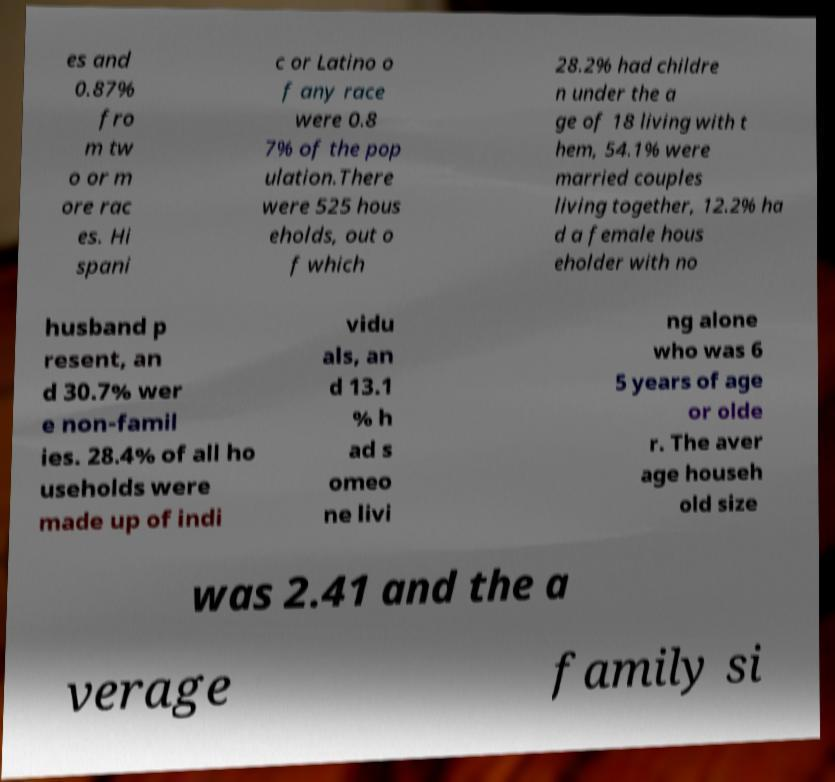Could you extract and type out the text from this image? es and 0.87% fro m tw o or m ore rac es. Hi spani c or Latino o f any race were 0.8 7% of the pop ulation.There were 525 hous eholds, out o f which 28.2% had childre n under the a ge of 18 living with t hem, 54.1% were married couples living together, 12.2% ha d a female hous eholder with no husband p resent, an d 30.7% wer e non-famil ies. 28.4% of all ho useholds were made up of indi vidu als, an d 13.1 % h ad s omeo ne livi ng alone who was 6 5 years of age or olde r. The aver age househ old size was 2.41 and the a verage family si 